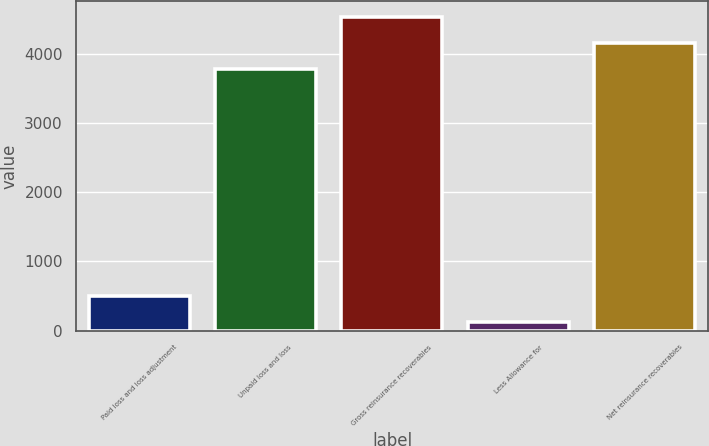<chart> <loc_0><loc_0><loc_500><loc_500><bar_chart><fcel>Paid loss and loss adjustment<fcel>Unpaid loss and loss<fcel>Gross reinsurance recoverables<fcel>Less Allowance for<fcel>Net reinsurance recoverables<nl><fcel>503.4<fcel>3773<fcel>4527.8<fcel>126<fcel>4150.4<nl></chart> 